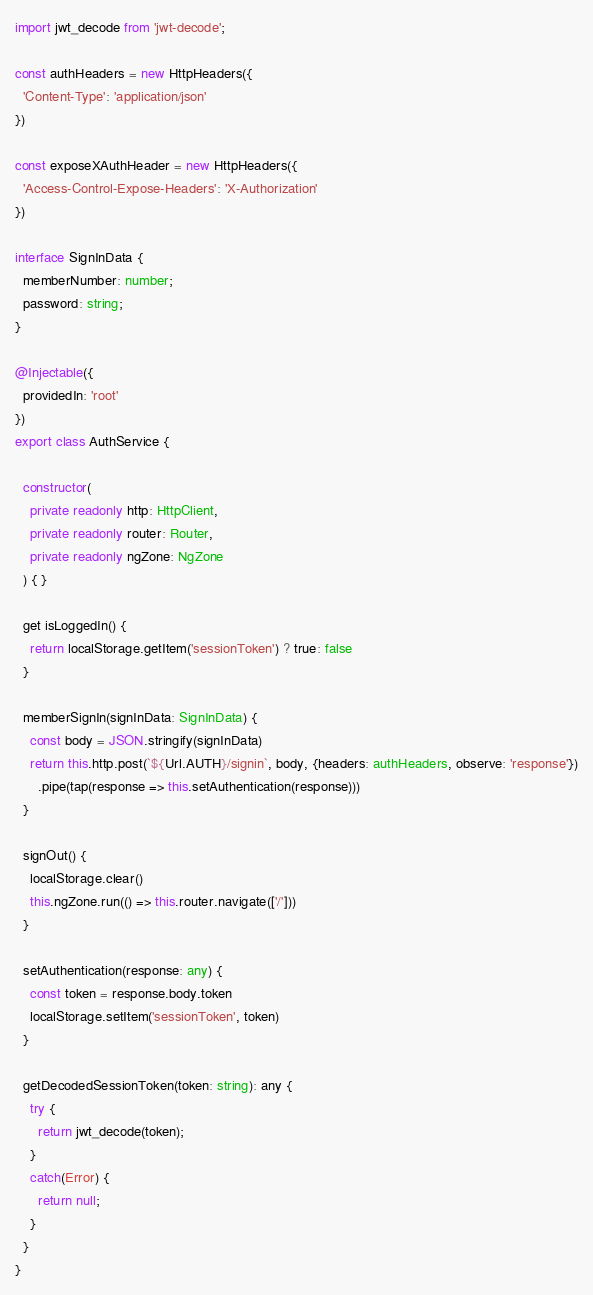Convert code to text. <code><loc_0><loc_0><loc_500><loc_500><_TypeScript_>import jwt_decode from 'jwt-decode';

const authHeaders = new HttpHeaders({
  'Content-Type': 'application/json'
})

const exposeXAuthHeader = new HttpHeaders({
  'Access-Control-Expose-Headers': 'X-Authorization'
})

interface SignInData {
  memberNumber: number;
  password: string;
}

@Injectable({
  providedIn: 'root'
})
export class AuthService {

  constructor(
    private readonly http: HttpClient,
    private readonly router: Router,
    private readonly ngZone: NgZone
  ) { }

  get isLoggedIn() {
    return localStorage.getItem('sessionToken') ? true: false
  }

  memberSignIn(signInData: SignInData) {
    const body = JSON.stringify(signInData)
    return this.http.post(`${Url.AUTH}/signin`, body, {headers: authHeaders, observe: 'response'})
      .pipe(tap(response => this.setAuthentication(response)))
  }

  signOut() {
    localStorage.clear()
    this.ngZone.run(() => this.router.navigate(['/']))
  }

  setAuthentication(response: any) {
    const token = response.body.token
    localStorage.setItem('sessionToken', token)
  }

  getDecodedSessionToken(token: string): any {
    try {
      return jwt_decode(token);
    }
    catch(Error) {
      return null;
    }
  }
}
</code> 